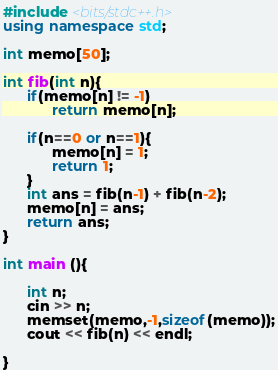<code> <loc_0><loc_0><loc_500><loc_500><_C++_>#include <bits/stdc++.h>
using namespace std;

int memo[50];

int fib(int n){
	  if(memo[n] != -1)
			return memo[n];
	  
	  if(n==0 or n==1){
			memo[n] = 1;
			return 1;
	  }
	  int ans = fib(n-1) + fib(n-2);
	  memo[n] = ans;
	  return ans;
}

int main (){

	  int n;
	  cin >> n;
	  memset(memo,-1,sizeof(memo));
	  cout << fib(n) << endl;

}</code> 